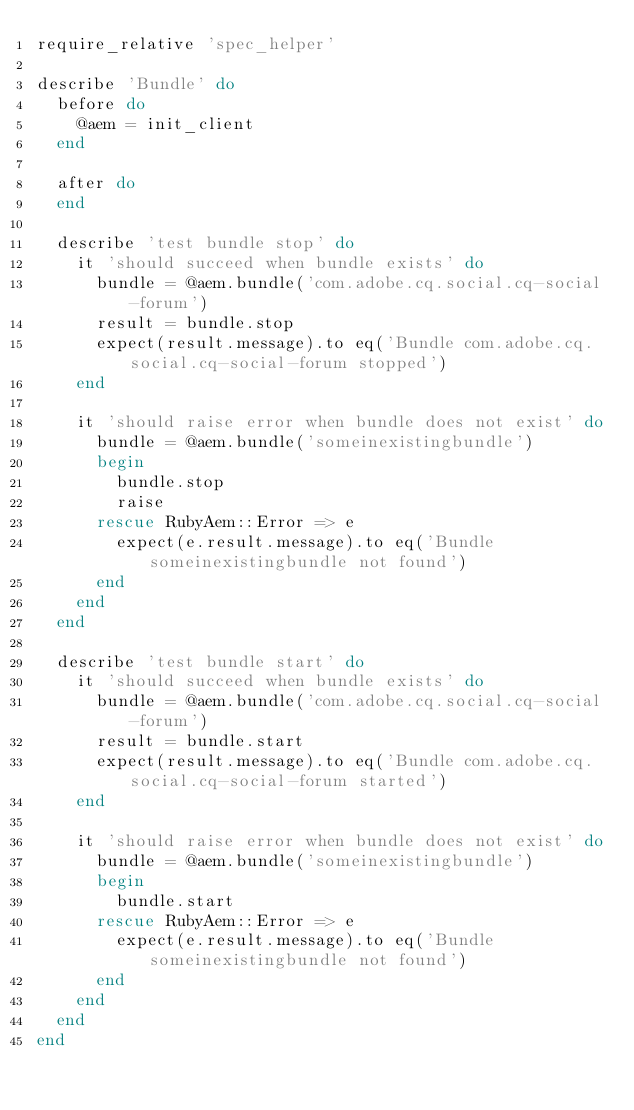Convert code to text. <code><loc_0><loc_0><loc_500><loc_500><_Ruby_>require_relative 'spec_helper'

describe 'Bundle' do
  before do
    @aem = init_client
  end

  after do
  end

  describe 'test bundle stop' do
    it 'should succeed when bundle exists' do
      bundle = @aem.bundle('com.adobe.cq.social.cq-social-forum')
      result = bundle.stop
      expect(result.message).to eq('Bundle com.adobe.cq.social.cq-social-forum stopped')
    end

    it 'should raise error when bundle does not exist' do
      bundle = @aem.bundle('someinexistingbundle')
      begin
        bundle.stop
        raise
      rescue RubyAem::Error => e
        expect(e.result.message).to eq('Bundle someinexistingbundle not found')
      end
    end
  end

  describe 'test bundle start' do
    it 'should succeed when bundle exists' do
      bundle = @aem.bundle('com.adobe.cq.social.cq-social-forum')
      result = bundle.start
      expect(result.message).to eq('Bundle com.adobe.cq.social.cq-social-forum started')
    end

    it 'should raise error when bundle does not exist' do
      bundle = @aem.bundle('someinexistingbundle')
      begin
        bundle.start
      rescue RubyAem::Error => e
        expect(e.result.message).to eq('Bundle someinexistingbundle not found')
      end
    end
  end
end
</code> 